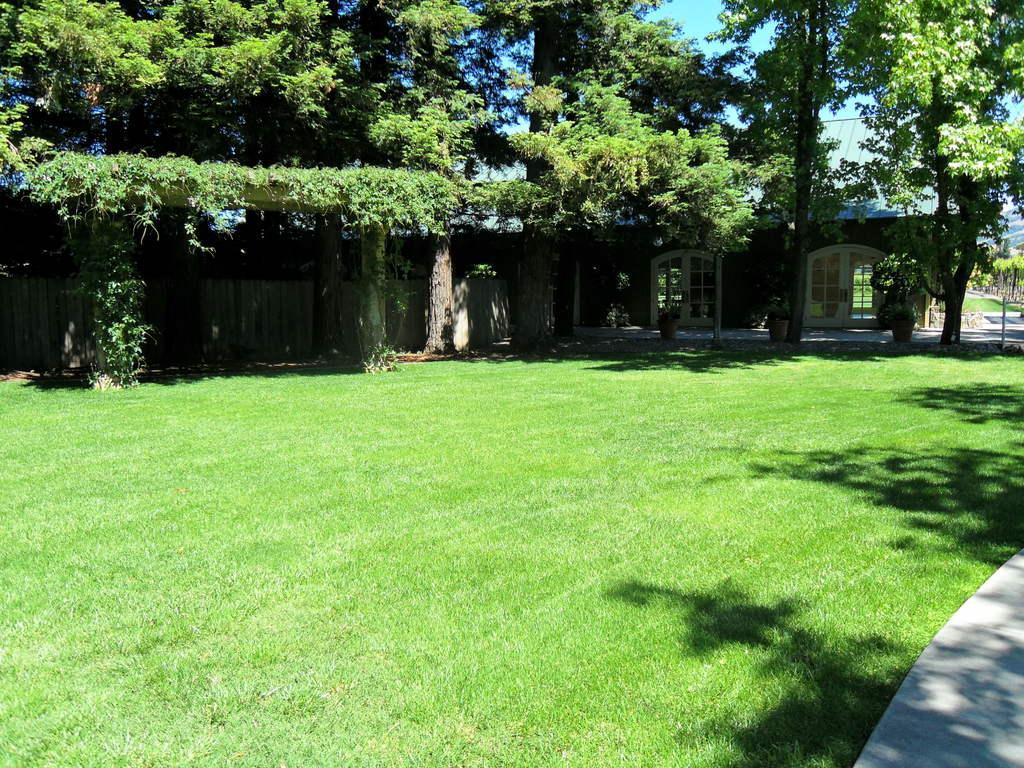Could you give a brief overview of what you see in this image? In this picture we can observe some grass on the ground. There are some trees. We can observe a wooden wall. In the background there is a sky. 